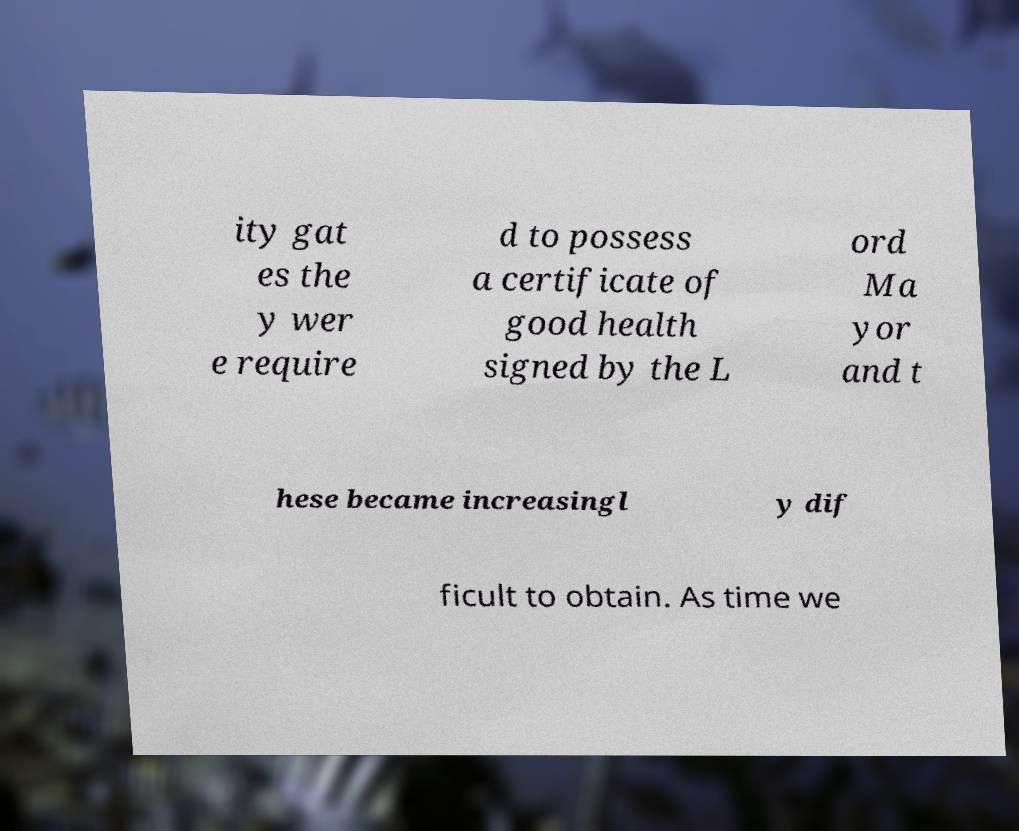There's text embedded in this image that I need extracted. Can you transcribe it verbatim? ity gat es the y wer e require d to possess a certificate of good health signed by the L ord Ma yor and t hese became increasingl y dif ficult to obtain. As time we 